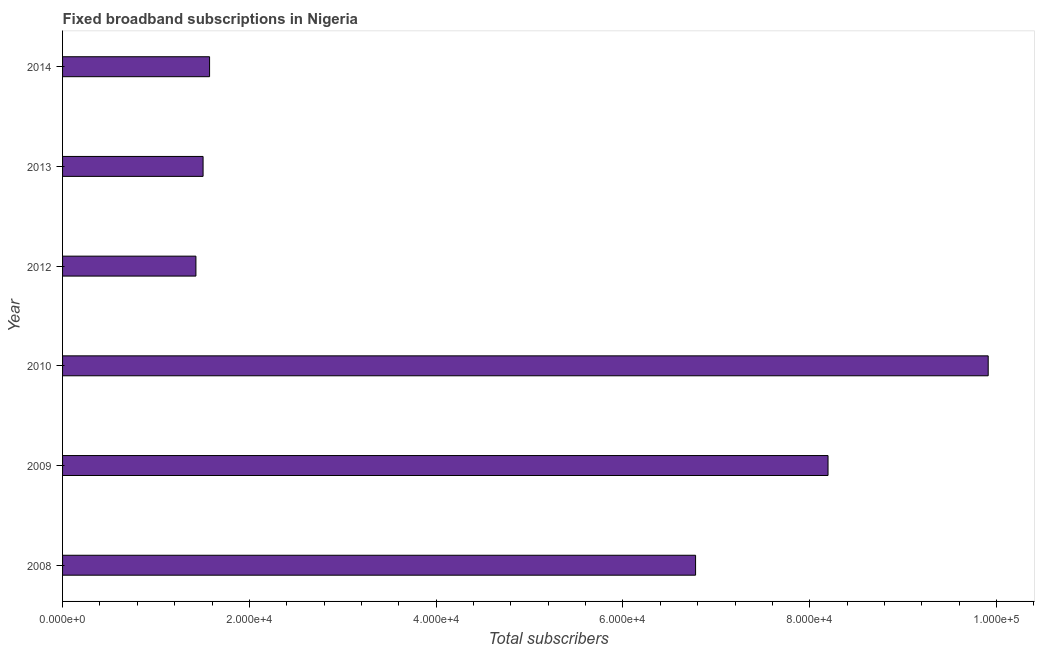Does the graph contain grids?
Your answer should be very brief. No. What is the title of the graph?
Ensure brevity in your answer.  Fixed broadband subscriptions in Nigeria. What is the label or title of the X-axis?
Keep it short and to the point. Total subscribers. What is the total number of fixed broadband subscriptions in 2009?
Provide a short and direct response. 8.20e+04. Across all years, what is the maximum total number of fixed broadband subscriptions?
Offer a terse response. 9.91e+04. Across all years, what is the minimum total number of fixed broadband subscriptions?
Your answer should be compact. 1.43e+04. In which year was the total number of fixed broadband subscriptions maximum?
Your response must be concise. 2010. In which year was the total number of fixed broadband subscriptions minimum?
Offer a very short reply. 2012. What is the sum of the total number of fixed broadband subscriptions?
Offer a very short reply. 2.94e+05. What is the difference between the total number of fixed broadband subscriptions in 2010 and 2014?
Offer a terse response. 8.34e+04. What is the average total number of fixed broadband subscriptions per year?
Give a very brief answer. 4.90e+04. What is the median total number of fixed broadband subscriptions?
Give a very brief answer. 4.18e+04. Do a majority of the years between 2008 and 2012 (inclusive) have total number of fixed broadband subscriptions greater than 100000 ?
Offer a very short reply. No. What is the ratio of the total number of fixed broadband subscriptions in 2010 to that in 2014?
Offer a very short reply. 6.3. What is the difference between the highest and the second highest total number of fixed broadband subscriptions?
Keep it short and to the point. 1.72e+04. What is the difference between the highest and the lowest total number of fixed broadband subscriptions?
Make the answer very short. 8.48e+04. In how many years, is the total number of fixed broadband subscriptions greater than the average total number of fixed broadband subscriptions taken over all years?
Ensure brevity in your answer.  3. How many years are there in the graph?
Your answer should be compact. 6. What is the difference between two consecutive major ticks on the X-axis?
Your response must be concise. 2.00e+04. Are the values on the major ticks of X-axis written in scientific E-notation?
Offer a very short reply. Yes. What is the Total subscribers of 2008?
Your answer should be very brief. 6.78e+04. What is the Total subscribers in 2009?
Provide a succinct answer. 8.20e+04. What is the Total subscribers of 2010?
Keep it short and to the point. 9.91e+04. What is the Total subscribers in 2012?
Provide a short and direct response. 1.43e+04. What is the Total subscribers in 2013?
Offer a terse response. 1.50e+04. What is the Total subscribers of 2014?
Offer a terse response. 1.57e+04. What is the difference between the Total subscribers in 2008 and 2009?
Give a very brief answer. -1.42e+04. What is the difference between the Total subscribers in 2008 and 2010?
Ensure brevity in your answer.  -3.13e+04. What is the difference between the Total subscribers in 2008 and 2012?
Provide a succinct answer. 5.35e+04. What is the difference between the Total subscribers in 2008 and 2013?
Give a very brief answer. 5.27e+04. What is the difference between the Total subscribers in 2008 and 2014?
Offer a terse response. 5.20e+04. What is the difference between the Total subscribers in 2009 and 2010?
Your answer should be compact. -1.72e+04. What is the difference between the Total subscribers in 2009 and 2012?
Make the answer very short. 6.77e+04. What is the difference between the Total subscribers in 2009 and 2013?
Provide a succinct answer. 6.69e+04. What is the difference between the Total subscribers in 2009 and 2014?
Offer a very short reply. 6.62e+04. What is the difference between the Total subscribers in 2010 and 2012?
Ensure brevity in your answer.  8.48e+04. What is the difference between the Total subscribers in 2010 and 2013?
Offer a terse response. 8.41e+04. What is the difference between the Total subscribers in 2010 and 2014?
Provide a succinct answer. 8.34e+04. What is the difference between the Total subscribers in 2012 and 2013?
Keep it short and to the point. -766. What is the difference between the Total subscribers in 2012 and 2014?
Give a very brief answer. -1461. What is the difference between the Total subscribers in 2013 and 2014?
Offer a terse response. -695. What is the ratio of the Total subscribers in 2008 to that in 2009?
Your response must be concise. 0.83. What is the ratio of the Total subscribers in 2008 to that in 2010?
Offer a terse response. 0.68. What is the ratio of the Total subscribers in 2008 to that in 2012?
Your response must be concise. 4.75. What is the ratio of the Total subscribers in 2008 to that in 2013?
Offer a terse response. 4.5. What is the ratio of the Total subscribers in 2008 to that in 2014?
Make the answer very short. 4.31. What is the ratio of the Total subscribers in 2009 to that in 2010?
Provide a short and direct response. 0.83. What is the ratio of the Total subscribers in 2009 to that in 2012?
Give a very brief answer. 5.74. What is the ratio of the Total subscribers in 2009 to that in 2013?
Keep it short and to the point. 5.45. What is the ratio of the Total subscribers in 2009 to that in 2014?
Give a very brief answer. 5.21. What is the ratio of the Total subscribers in 2010 to that in 2012?
Offer a terse response. 6.94. What is the ratio of the Total subscribers in 2010 to that in 2013?
Give a very brief answer. 6.59. What is the ratio of the Total subscribers in 2010 to that in 2014?
Keep it short and to the point. 6.3. What is the ratio of the Total subscribers in 2012 to that in 2013?
Ensure brevity in your answer.  0.95. What is the ratio of the Total subscribers in 2012 to that in 2014?
Make the answer very short. 0.91. What is the ratio of the Total subscribers in 2013 to that in 2014?
Your answer should be very brief. 0.96. 